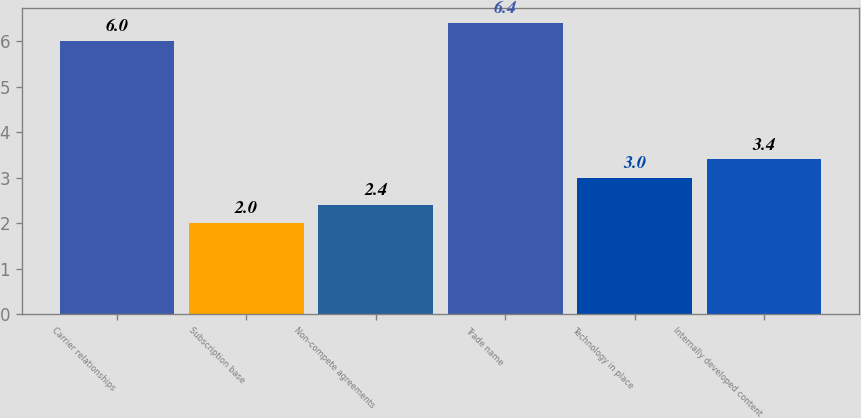Convert chart. <chart><loc_0><loc_0><loc_500><loc_500><bar_chart><fcel>Carrier relationships<fcel>Subscription base<fcel>Non-compete agreements<fcel>Trade name<fcel>Technology in place<fcel>Internally developed content<nl><fcel>6<fcel>2<fcel>2.4<fcel>6.4<fcel>3<fcel>3.4<nl></chart> 